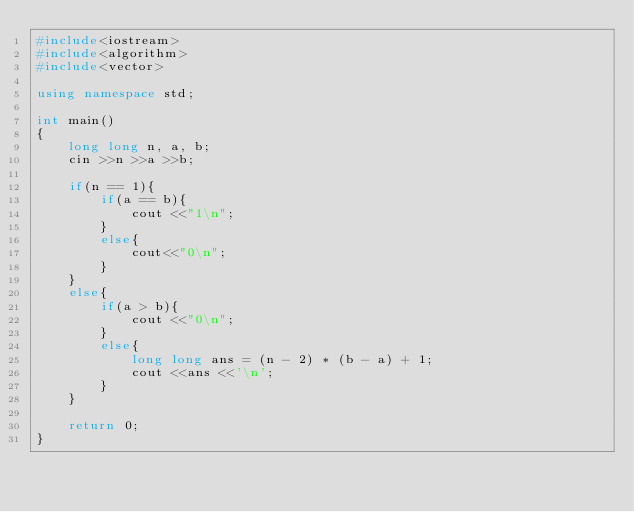<code> <loc_0><loc_0><loc_500><loc_500><_C++_>#include<iostream>
#include<algorithm>
#include<vector>

using namespace std;

int main()
{
	long long n, a, b;
	cin >>n >>a >>b;

	if(n == 1){
		if(a == b){
			cout <<"1\n";
		}
		else{
			cout<<"0\n";
		}
	}
	else{
		if(a > b){
			cout <<"0\n";
		}
		else{
			long long ans = (n - 2) * (b - a) + 1;
			cout <<ans <<'\n';
		}
	}

	return 0;
}
</code> 